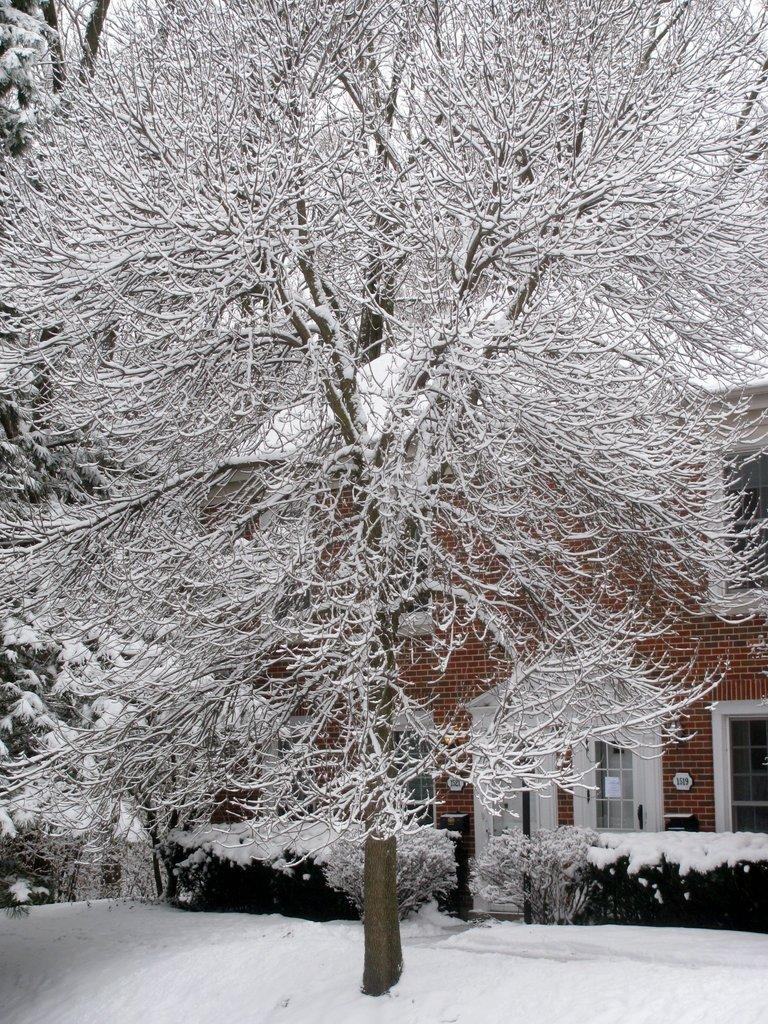What is the main subject of the image? The main subject of the image is a tree covered with snow. What can be seen in the background of the image? There is a building in the background of the image. What is the color of the building? The building is brown in color. What is the color of the sky in the image? The sky is white in color. What type of bottle can be seen in the bedroom in the image? There is no bottle or bedroom present in the image; it features a tree covered with snow and a brown building in the background. 